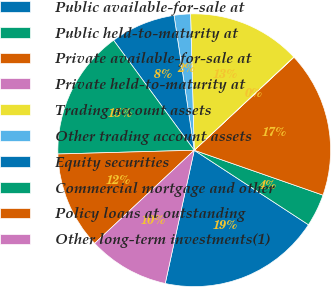Convert chart. <chart><loc_0><loc_0><loc_500><loc_500><pie_chart><fcel>Public available-for-sale at<fcel>Public held-to-maturity at<fcel>Private available-for-sale at<fcel>Private held-to-maturity at<fcel>Trading account assets<fcel>Other trading account assets<fcel>Equity securities<fcel>Commercial mortgage and other<fcel>Policy loans at outstanding<fcel>Other long-term investments(1)<nl><fcel>19.21%<fcel>3.86%<fcel>17.29%<fcel>0.03%<fcel>13.45%<fcel>1.94%<fcel>7.7%<fcel>15.37%<fcel>11.53%<fcel>9.62%<nl></chart> 